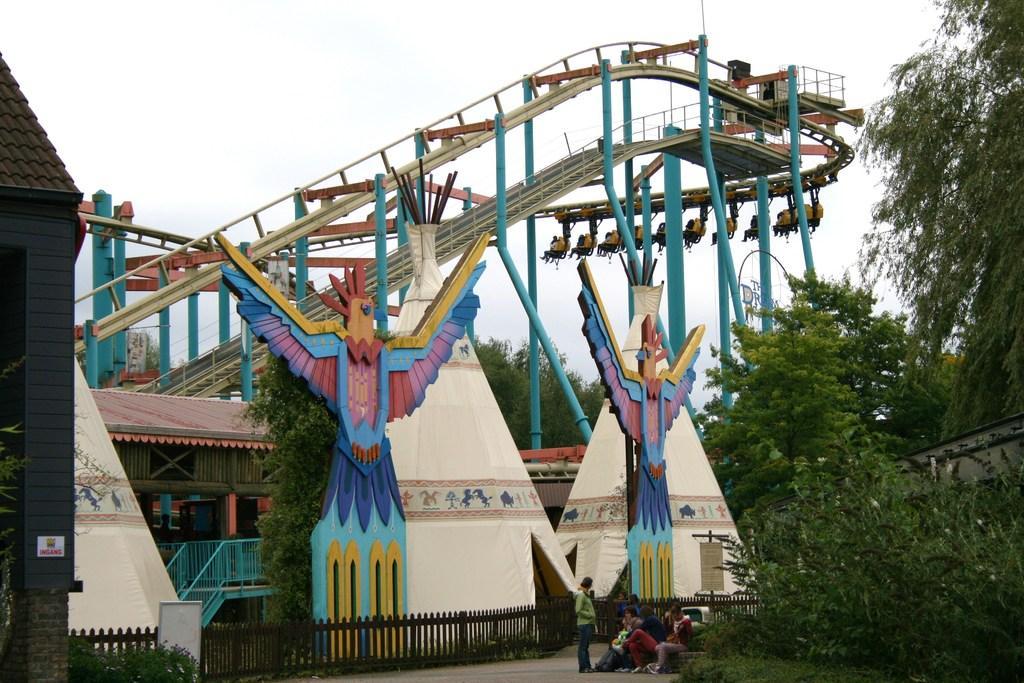Can you describe this image briefly? In this picture there is a person standing and there are group of people sitting. At the back there is a building and there are games and trees. At the bottom there is a wooden railing and there are plants. At the top there is sky. 